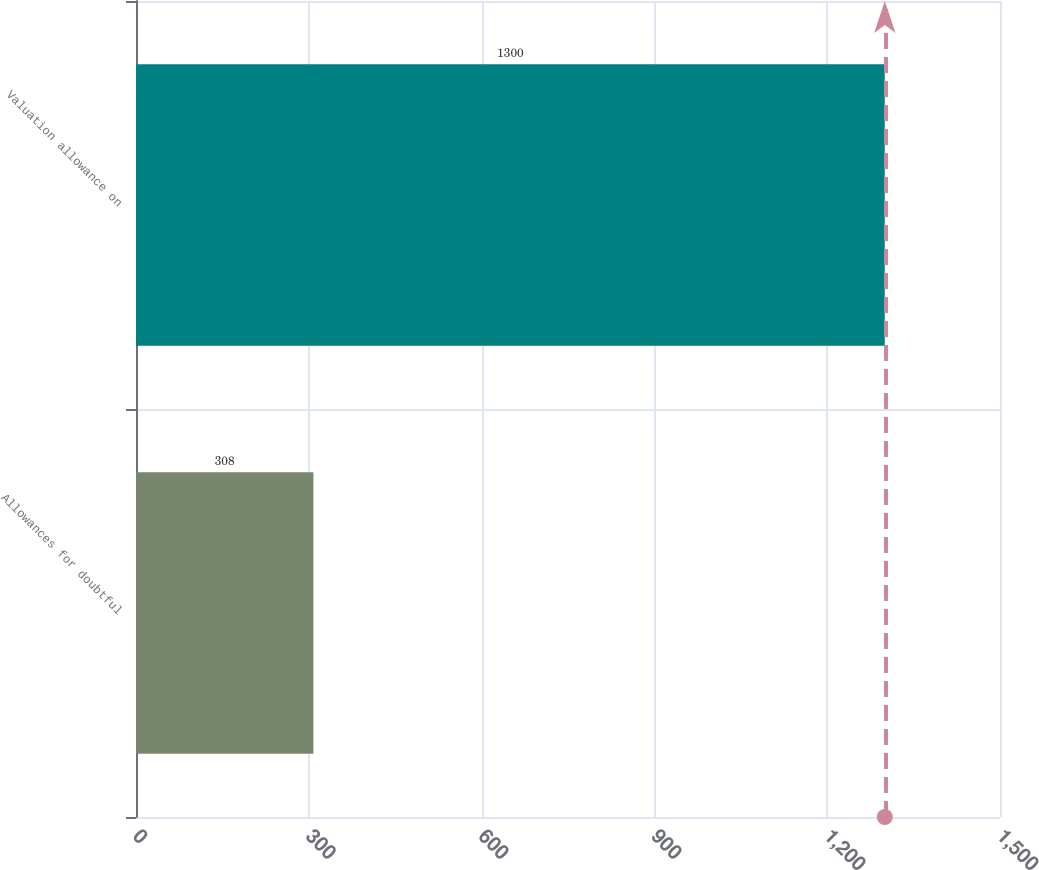<chart> <loc_0><loc_0><loc_500><loc_500><bar_chart><fcel>Allowances for doubtful<fcel>Valuation allowance on<nl><fcel>308<fcel>1300<nl></chart> 